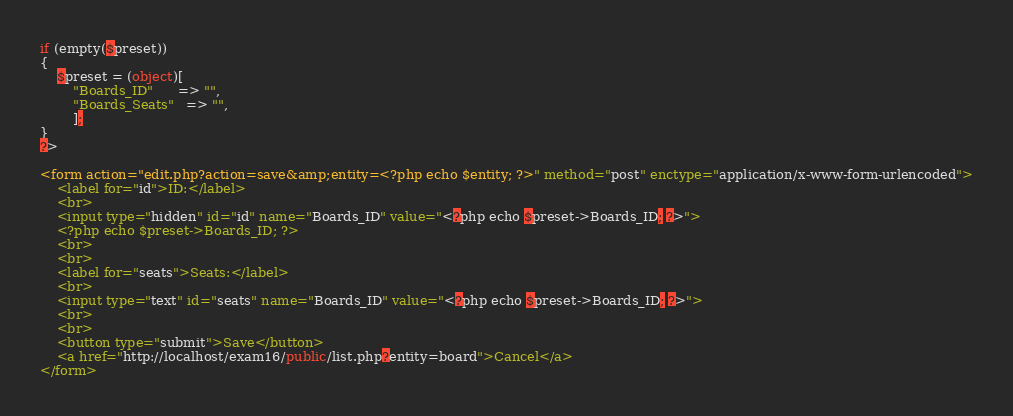Convert code to text. <code><loc_0><loc_0><loc_500><loc_500><_VisualBasic_>if (empty($preset))
{
    $preset = (object)[
        "Boards_ID"      => "",
        "Boards_Seats"   => "",
        ];
}
?>

<form action="edit.php?action=save&amp;entity=<?php echo $entity; ?>" method="post" enctype="application/x-www-form-urlencoded">
    <label for="id">ID:</label>
    <br>
    <input type="hidden" id="id" name="Boards_ID" value="<?php echo $preset->Boards_ID; ?>">
    <?php echo $preset->Boards_ID; ?>
    <br>
    <br>
    <label for="seats">Seats:</label>
    <br>
    <input type="text" id="seats" name="Boards_ID" value="<?php echo $preset->Boards_ID; ?>">
    <br>
    <br>
    <button type="submit">Save</button>
    <a href="http://localhost/exam16/public/list.php?entity=board">Cancel</a>
</form></code> 